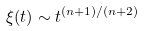<formula> <loc_0><loc_0><loc_500><loc_500>\xi ( t ) \sim t ^ { ( n + 1 ) / ( n + 2 ) }</formula> 